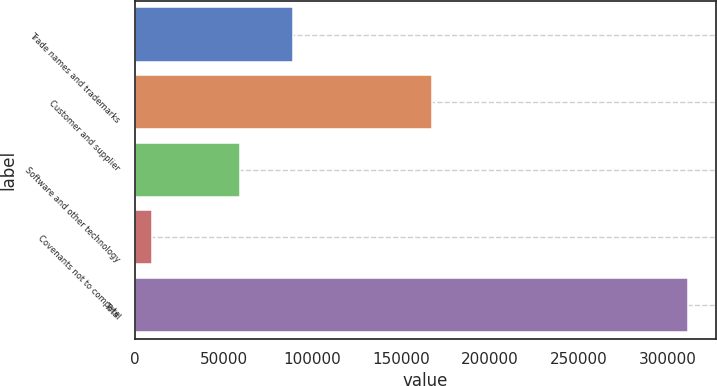<chart> <loc_0><loc_0><loc_500><loc_500><bar_chart><fcel>Trade names and trademarks<fcel>Customer and supplier<fcel>Software and other technology<fcel>Covenants not to compete<fcel>Total<nl><fcel>89251.8<fcel>167532<fcel>59081<fcel>9798<fcel>311506<nl></chart> 